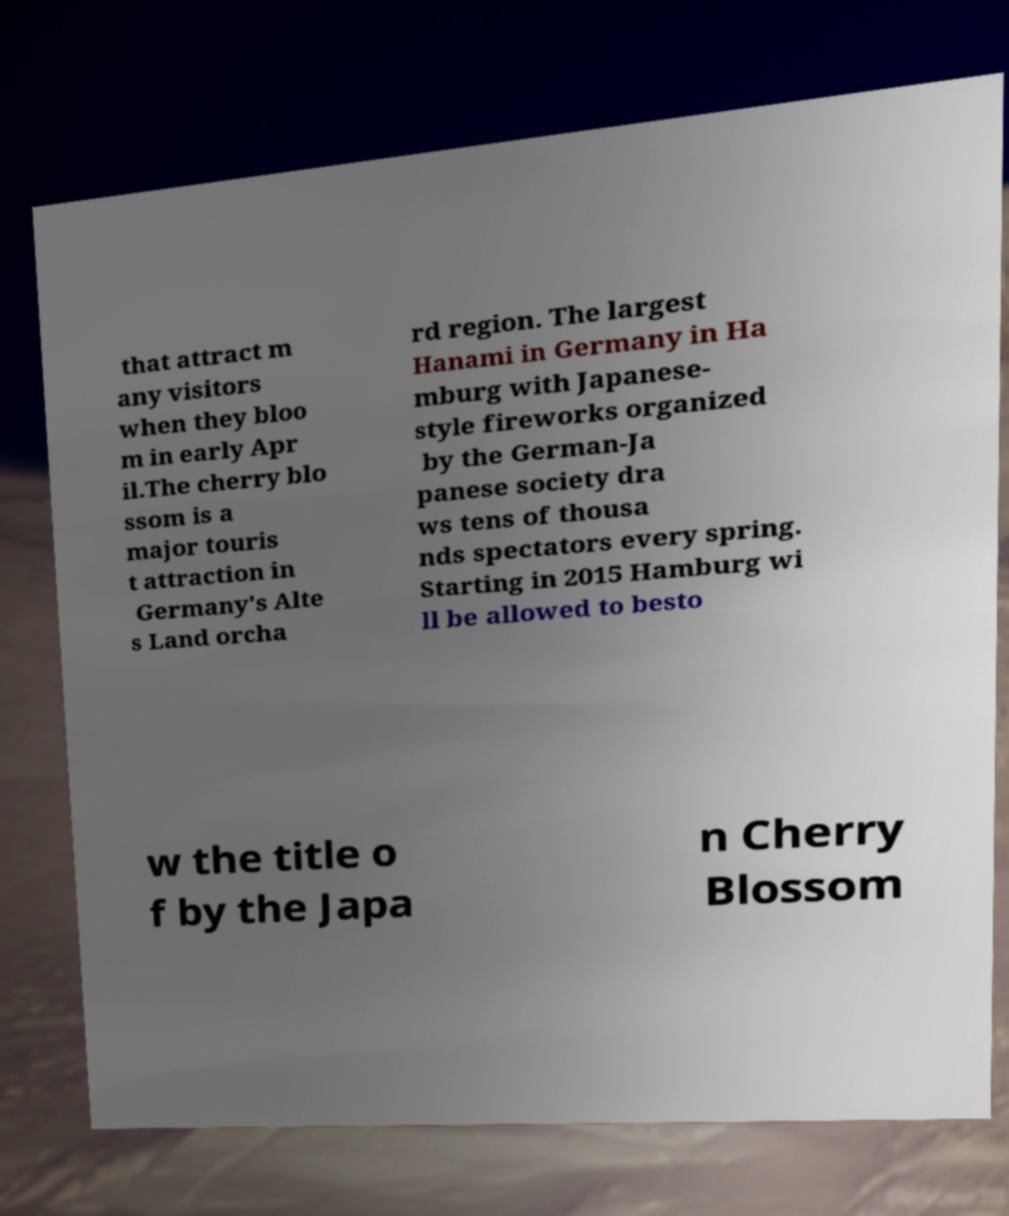Please identify and transcribe the text found in this image. that attract m any visitors when they bloo m in early Apr il.The cherry blo ssom is a major touris t attraction in Germany's Alte s Land orcha rd region. The largest Hanami in Germany in Ha mburg with Japanese- style fireworks organized by the German-Ja panese society dra ws tens of thousa nds spectators every spring. Starting in 2015 Hamburg wi ll be allowed to besto w the title o f by the Japa n Cherry Blossom 